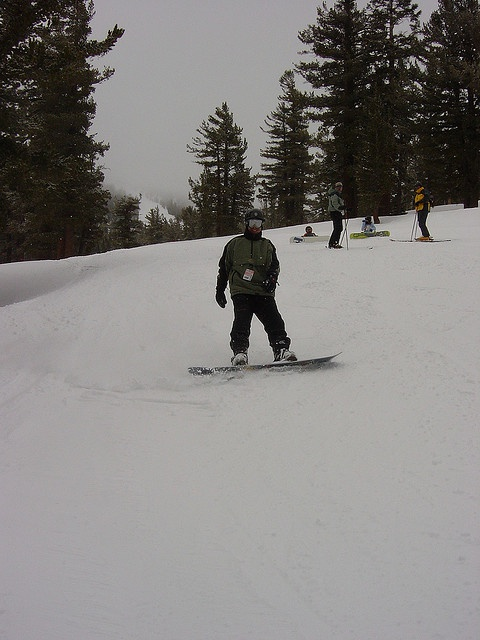Describe the objects in this image and their specific colors. I can see people in black, darkgray, gray, and lightgray tones, snowboard in black, gray, and darkgray tones, people in black, gray, and darkgray tones, people in black, olive, and maroon tones, and snowboard in black, darkgreen, gray, and darkgray tones in this image. 